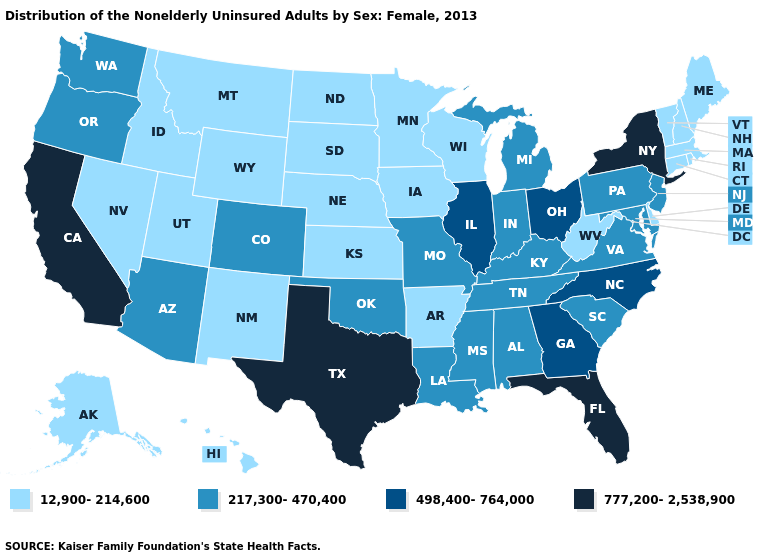Does Illinois have a lower value than Texas?
Answer briefly. Yes. Among the states that border South Dakota , which have the highest value?
Give a very brief answer. Iowa, Minnesota, Montana, Nebraska, North Dakota, Wyoming. Name the states that have a value in the range 217,300-470,400?
Keep it brief. Alabama, Arizona, Colorado, Indiana, Kentucky, Louisiana, Maryland, Michigan, Mississippi, Missouri, New Jersey, Oklahoma, Oregon, Pennsylvania, South Carolina, Tennessee, Virginia, Washington. Does New Hampshire have the highest value in the Northeast?
Write a very short answer. No. What is the value of California?
Answer briefly. 777,200-2,538,900. Does the map have missing data?
Quick response, please. No. Does Massachusetts have the lowest value in the USA?
Keep it brief. Yes. Name the states that have a value in the range 12,900-214,600?
Give a very brief answer. Alaska, Arkansas, Connecticut, Delaware, Hawaii, Idaho, Iowa, Kansas, Maine, Massachusetts, Minnesota, Montana, Nebraska, Nevada, New Hampshire, New Mexico, North Dakota, Rhode Island, South Dakota, Utah, Vermont, West Virginia, Wisconsin, Wyoming. Which states have the lowest value in the USA?
Give a very brief answer. Alaska, Arkansas, Connecticut, Delaware, Hawaii, Idaho, Iowa, Kansas, Maine, Massachusetts, Minnesota, Montana, Nebraska, Nevada, New Hampshire, New Mexico, North Dakota, Rhode Island, South Dakota, Utah, Vermont, West Virginia, Wisconsin, Wyoming. Name the states that have a value in the range 777,200-2,538,900?
Keep it brief. California, Florida, New York, Texas. Name the states that have a value in the range 12,900-214,600?
Give a very brief answer. Alaska, Arkansas, Connecticut, Delaware, Hawaii, Idaho, Iowa, Kansas, Maine, Massachusetts, Minnesota, Montana, Nebraska, Nevada, New Hampshire, New Mexico, North Dakota, Rhode Island, South Dakota, Utah, Vermont, West Virginia, Wisconsin, Wyoming. Name the states that have a value in the range 777,200-2,538,900?
Concise answer only. California, Florida, New York, Texas. Among the states that border Massachusetts , which have the highest value?
Write a very short answer. New York. Which states have the highest value in the USA?
Write a very short answer. California, Florida, New York, Texas. How many symbols are there in the legend?
Concise answer only. 4. 